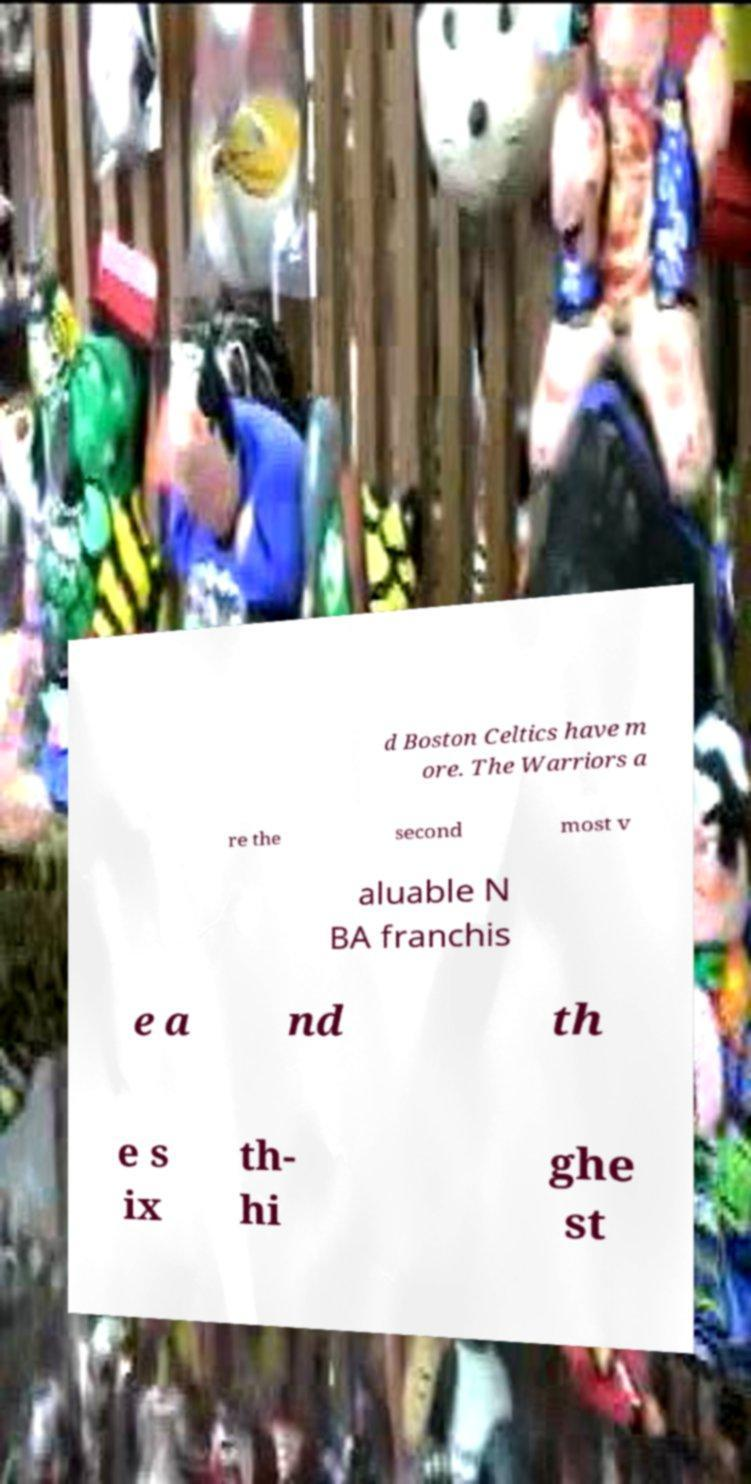Can you accurately transcribe the text from the provided image for me? d Boston Celtics have m ore. The Warriors a re the second most v aluable N BA franchis e a nd th e s ix th- hi ghe st 